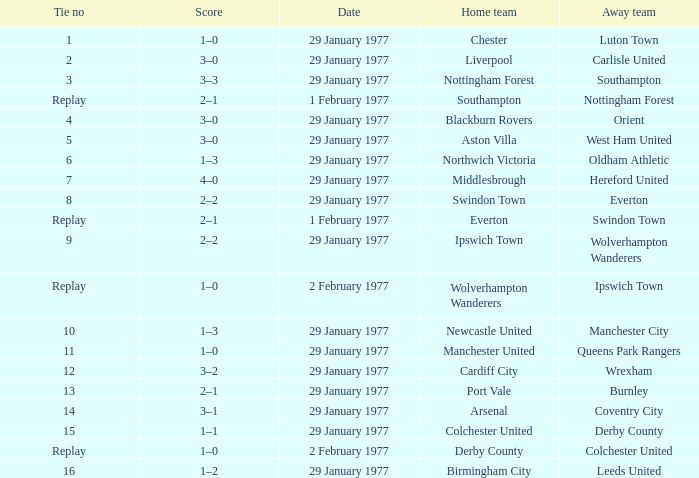What is the tie number when the home team is Port Vale? 13.0. 